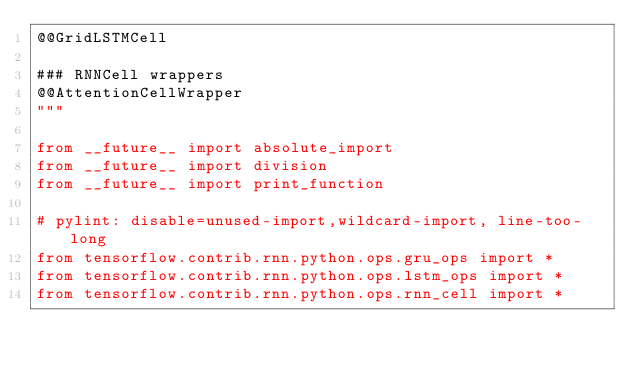<code> <loc_0><loc_0><loc_500><loc_500><_Python_>@@GridLSTMCell

### RNNCell wrappers
@@AttentionCellWrapper
"""

from __future__ import absolute_import
from __future__ import division
from __future__ import print_function

# pylint: disable=unused-import,wildcard-import, line-too-long
from tensorflow.contrib.rnn.python.ops.gru_ops import *
from tensorflow.contrib.rnn.python.ops.lstm_ops import *
from tensorflow.contrib.rnn.python.ops.rnn_cell import *
</code> 